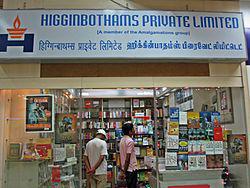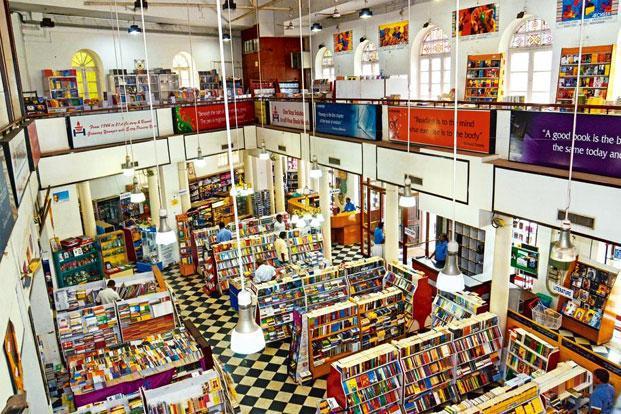The first image is the image on the left, the second image is the image on the right. For the images shown, is this caption "Although the image to the left is a bookstore, there are no actual books visible." true? Answer yes or no. No. The first image is the image on the left, the second image is the image on the right. For the images displayed, is the sentence "The right image shows an arched opening at the left end of a row of shelves in a shop's interior." factually correct? Answer yes or no. No. 